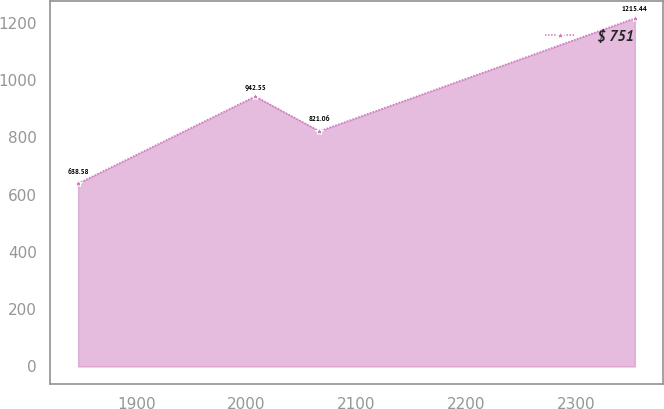<chart> <loc_0><loc_0><loc_500><loc_500><line_chart><ecel><fcel>$ 751<nl><fcel>1846.9<fcel>638.58<nl><fcel>2007.97<fcel>942.55<nl><fcel>2066.52<fcel>821.06<nl><fcel>2353.7<fcel>1215.44<nl></chart> 